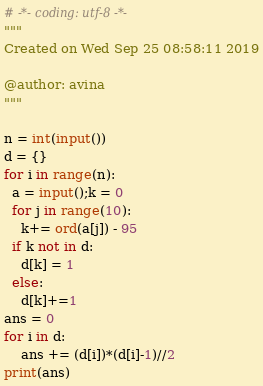Convert code to text. <code><loc_0><loc_0><loc_500><loc_500><_Python_># -*- coding: utf-8 -*-
"""
Created on Wed Sep 25 08:58:11 2019

@author: avina
"""

n = int(input())
d = {}
for i in range(n):
  a = input();k = 0
  for j in range(10):
    k+= ord(a[j]) - 95
  if k not in d:
    d[k] = 1
  else:
    d[k]+=1
ans = 0
for i in d:
    ans += (d[i])*(d[i]-1)//2
print(ans)</code> 